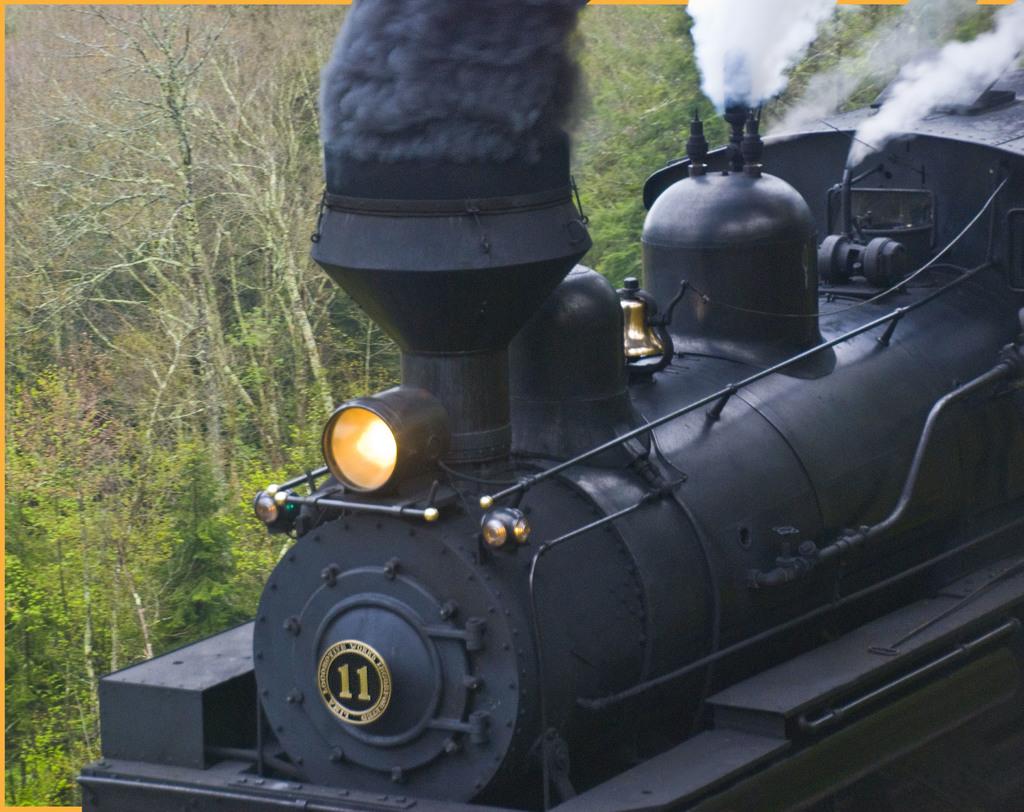What is the number on the train?
Provide a succinct answer. 11. Wht number is on the front of the train?
Ensure brevity in your answer.  11. 